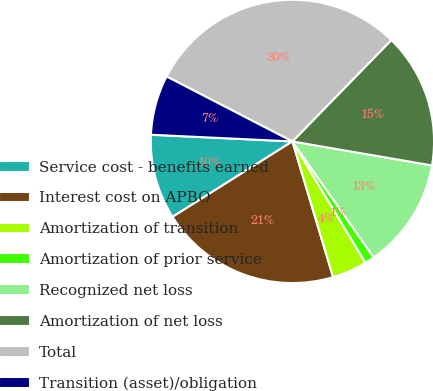Convert chart to OTSL. <chart><loc_0><loc_0><loc_500><loc_500><pie_chart><fcel>Service cost - benefits earned<fcel>Interest cost on APBO<fcel>Amortization of transition<fcel>Amortization of prior service<fcel>Recognized net loss<fcel>Amortization of net loss<fcel>Total<fcel>Transition (asset)/obligation<nl><fcel>9.69%<fcel>20.7%<fcel>3.98%<fcel>1.12%<fcel>12.55%<fcel>15.41%<fcel>29.71%<fcel>6.83%<nl></chart> 